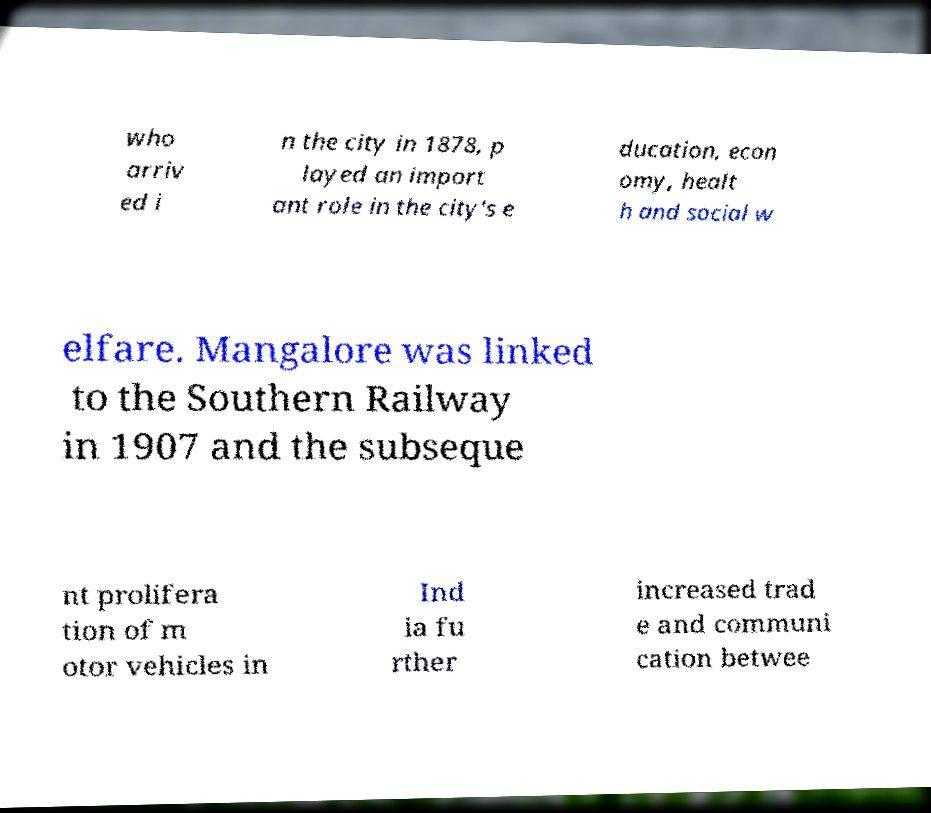Can you read and provide the text displayed in the image?This photo seems to have some interesting text. Can you extract and type it out for me? who arriv ed i n the city in 1878, p layed an import ant role in the city's e ducation, econ omy, healt h and social w elfare. Mangalore was linked to the Southern Railway in 1907 and the subseque nt prolifera tion of m otor vehicles in Ind ia fu rther increased trad e and communi cation betwee 